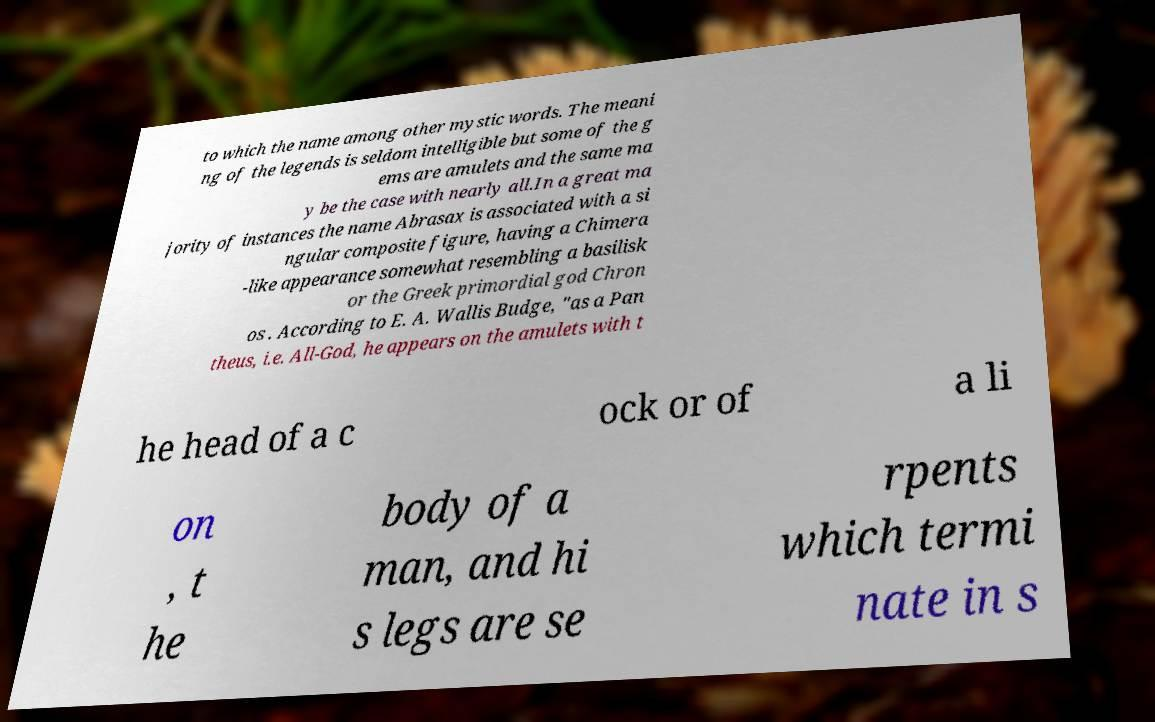Could you assist in decoding the text presented in this image and type it out clearly? to which the name among other mystic words. The meani ng of the legends is seldom intelligible but some of the g ems are amulets and the same ma y be the case with nearly all.In a great ma jority of instances the name Abrasax is associated with a si ngular composite figure, having a Chimera -like appearance somewhat resembling a basilisk or the Greek primordial god Chron os . According to E. A. Wallis Budge, "as a Pan theus, i.e. All-God, he appears on the amulets with t he head of a c ock or of a li on , t he body of a man, and hi s legs are se rpents which termi nate in s 